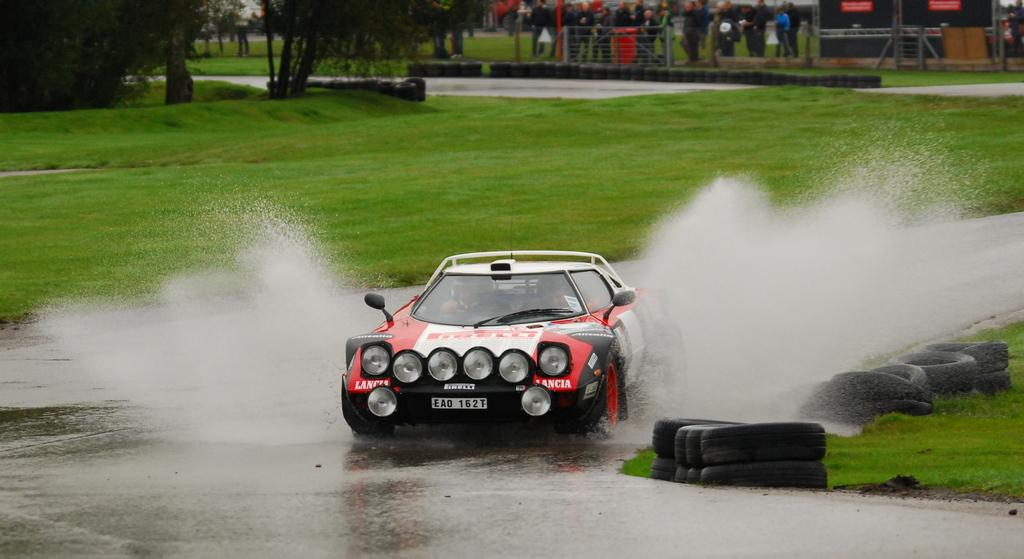What is the main subject of the image? The main subject of the image is a car. What is the car doing in the image? The car is raising off the road. What can be seen beside the road in the image? There is grass beside the road. What is visible in the background of the image? There is a fencing visible in the image. What are the people near the fencing doing? The people standing near the fencing are watching something. What type of stew is being served in the image? There is no stew present in the image; it features a car raising off the road and people watching something. 